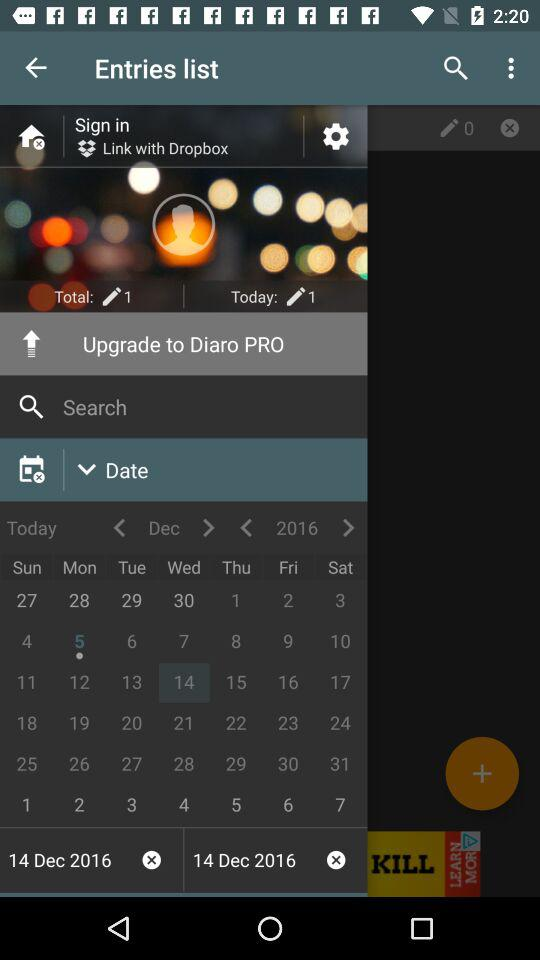How many entries are there today?
Answer the question using a single word or phrase. 1 